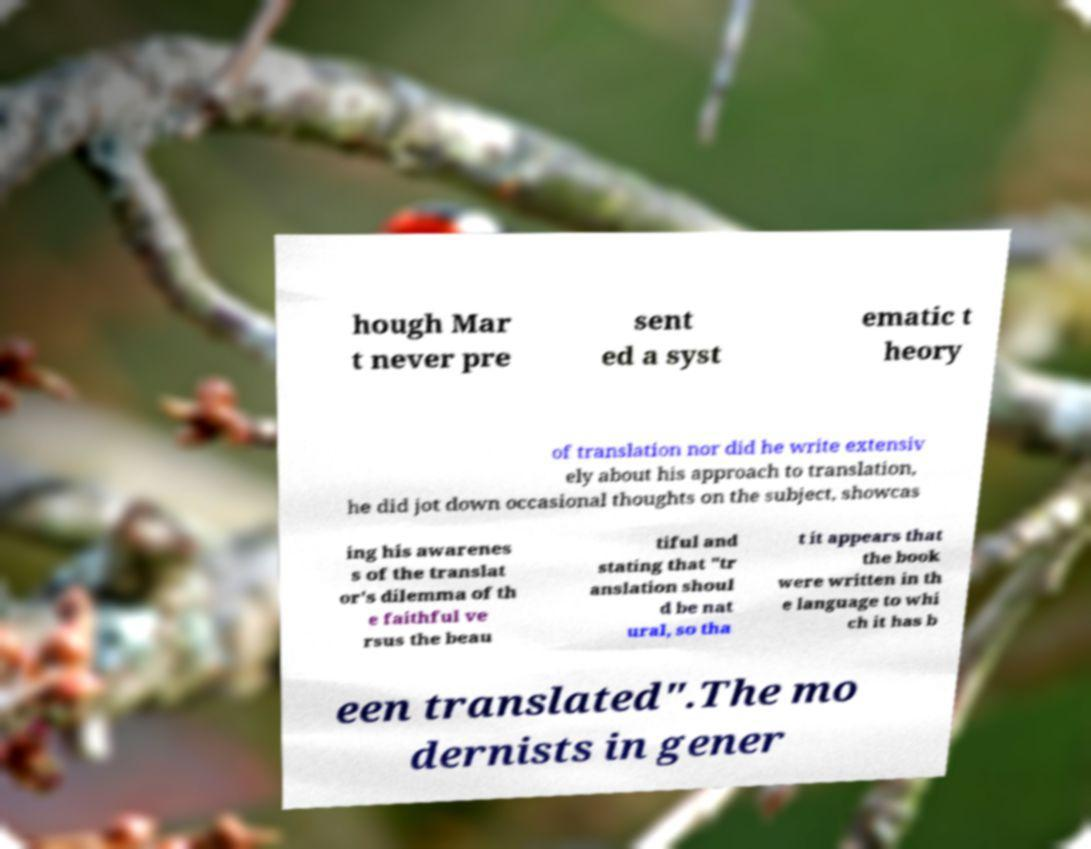Can you read and provide the text displayed in the image?This photo seems to have some interesting text. Can you extract and type it out for me? hough Mar t never pre sent ed a syst ematic t heory of translation nor did he write extensiv ely about his approach to translation, he did jot down occasional thoughts on the subject, showcas ing his awarenes s of the translat or's dilemma of th e faithful ve rsus the beau tiful and stating that "tr anslation shoul d be nat ural, so tha t it appears that the book were written in th e language to whi ch it has b een translated".The mo dernists in gener 